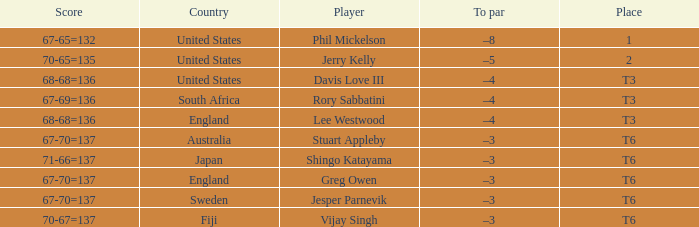Name the score for vijay singh 70-67=137. 